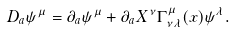Convert formula to latex. <formula><loc_0><loc_0><loc_500><loc_500>D _ { a } \psi ^ { \mu } = \partial _ { a } \psi ^ { \mu } + \partial _ { a } X ^ { \nu } \Gamma ^ { \mu } _ { \nu \lambda } ( x ) \psi ^ { \lambda } .</formula> 